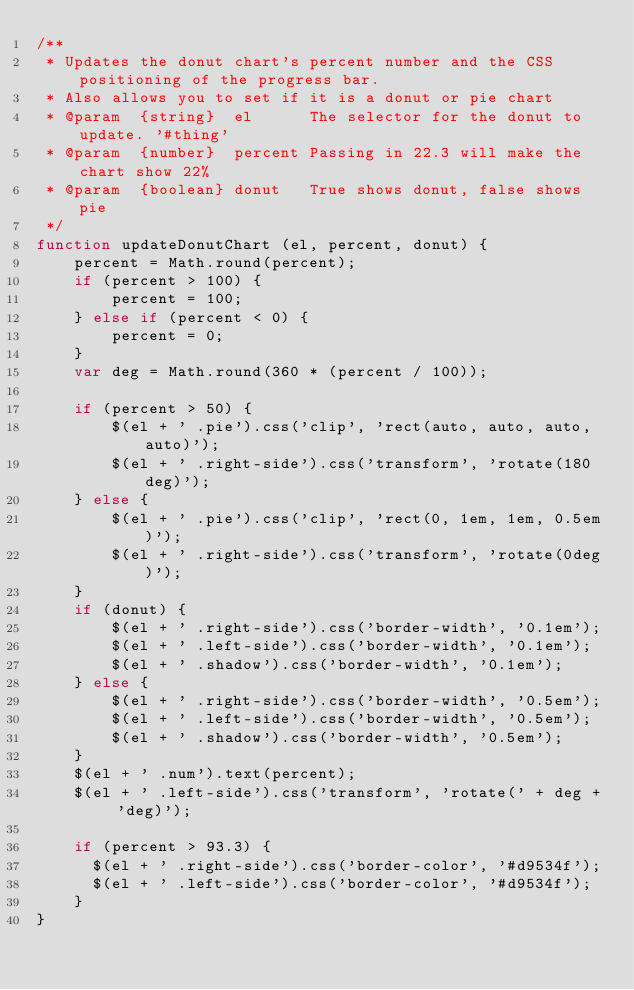Convert code to text. <code><loc_0><loc_0><loc_500><loc_500><_JavaScript_>/**
 * Updates the donut chart's percent number and the CSS positioning of the progress bar.
 * Also allows you to set if it is a donut or pie chart
 * @param  {string}  el      The selector for the donut to update. '#thing'
 * @param  {number}  percent Passing in 22.3 will make the chart show 22%
 * @param  {boolean} donut   True shows donut, false shows pie
 */
function updateDonutChart (el, percent, donut) {
    percent = Math.round(percent);
    if (percent > 100) {
        percent = 100;
    } else if (percent < 0) {
        percent = 0;
    }
    var deg = Math.round(360 * (percent / 100));

    if (percent > 50) {
        $(el + ' .pie').css('clip', 'rect(auto, auto, auto, auto)');
        $(el + ' .right-side').css('transform', 'rotate(180deg)');
    } else {
        $(el + ' .pie').css('clip', 'rect(0, 1em, 1em, 0.5em)');
        $(el + ' .right-side').css('transform', 'rotate(0deg)');
    }
    if (donut) {
        $(el + ' .right-side').css('border-width', '0.1em');
        $(el + ' .left-side').css('border-width', '0.1em');
        $(el + ' .shadow').css('border-width', '0.1em');
    } else {
        $(el + ' .right-side').css('border-width', '0.5em');
        $(el + ' .left-side').css('border-width', '0.5em');
        $(el + ' .shadow').css('border-width', '0.5em');
    }
    $(el + ' .num').text(percent);
    $(el + ' .left-side').css('transform', 'rotate(' + deg + 'deg)');

    if (percent > 93.3) {
      $(el + ' .right-side').css('border-color', '#d9534f');
      $(el + ' .left-side').css('border-color', '#d9534f');
    }
}
</code> 